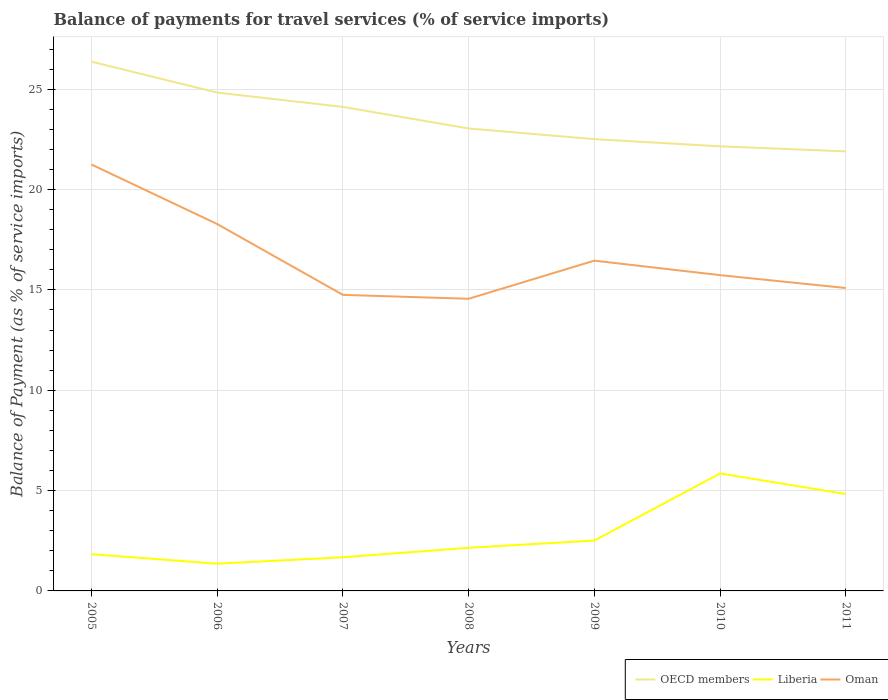Does the line corresponding to OECD members intersect with the line corresponding to Oman?
Your response must be concise. No. Is the number of lines equal to the number of legend labels?
Your answer should be very brief. Yes. Across all years, what is the maximum balance of payments for travel services in Oman?
Your answer should be very brief. 14.56. In which year was the balance of payments for travel services in OECD members maximum?
Ensure brevity in your answer.  2011. What is the total balance of payments for travel services in Oman in the graph?
Ensure brevity in your answer.  0.72. What is the difference between the highest and the second highest balance of payments for travel services in Oman?
Your answer should be compact. 6.69. What is the difference between the highest and the lowest balance of payments for travel services in Oman?
Your answer should be very brief. 2. Is the balance of payments for travel services in Oman strictly greater than the balance of payments for travel services in Liberia over the years?
Your answer should be compact. No. How many years are there in the graph?
Make the answer very short. 7. What is the difference between two consecutive major ticks on the Y-axis?
Give a very brief answer. 5. Are the values on the major ticks of Y-axis written in scientific E-notation?
Offer a terse response. No. Does the graph contain any zero values?
Your response must be concise. No. How many legend labels are there?
Your response must be concise. 3. What is the title of the graph?
Offer a terse response. Balance of payments for travel services (% of service imports). Does "Czech Republic" appear as one of the legend labels in the graph?
Give a very brief answer. No. What is the label or title of the Y-axis?
Keep it short and to the point. Balance of Payment (as % of service imports). What is the Balance of Payment (as % of service imports) in OECD members in 2005?
Keep it short and to the point. 26.37. What is the Balance of Payment (as % of service imports) of Liberia in 2005?
Give a very brief answer. 1.83. What is the Balance of Payment (as % of service imports) of Oman in 2005?
Give a very brief answer. 21.25. What is the Balance of Payment (as % of service imports) in OECD members in 2006?
Your answer should be compact. 24.83. What is the Balance of Payment (as % of service imports) of Liberia in 2006?
Provide a succinct answer. 1.36. What is the Balance of Payment (as % of service imports) in Oman in 2006?
Your response must be concise. 18.28. What is the Balance of Payment (as % of service imports) in OECD members in 2007?
Ensure brevity in your answer.  24.12. What is the Balance of Payment (as % of service imports) of Liberia in 2007?
Provide a succinct answer. 1.68. What is the Balance of Payment (as % of service imports) in Oman in 2007?
Give a very brief answer. 14.75. What is the Balance of Payment (as % of service imports) of OECD members in 2008?
Provide a succinct answer. 23.04. What is the Balance of Payment (as % of service imports) in Liberia in 2008?
Give a very brief answer. 2.15. What is the Balance of Payment (as % of service imports) of Oman in 2008?
Provide a succinct answer. 14.56. What is the Balance of Payment (as % of service imports) in OECD members in 2009?
Your answer should be compact. 22.51. What is the Balance of Payment (as % of service imports) of Liberia in 2009?
Give a very brief answer. 2.51. What is the Balance of Payment (as % of service imports) in Oman in 2009?
Your answer should be very brief. 16.46. What is the Balance of Payment (as % of service imports) in OECD members in 2010?
Provide a short and direct response. 22.15. What is the Balance of Payment (as % of service imports) of Liberia in 2010?
Offer a terse response. 5.85. What is the Balance of Payment (as % of service imports) of Oman in 2010?
Provide a short and direct response. 15.74. What is the Balance of Payment (as % of service imports) of OECD members in 2011?
Offer a terse response. 21.9. What is the Balance of Payment (as % of service imports) in Liberia in 2011?
Your answer should be compact. 4.83. What is the Balance of Payment (as % of service imports) of Oman in 2011?
Provide a short and direct response. 15.09. Across all years, what is the maximum Balance of Payment (as % of service imports) of OECD members?
Offer a very short reply. 26.37. Across all years, what is the maximum Balance of Payment (as % of service imports) of Liberia?
Provide a succinct answer. 5.85. Across all years, what is the maximum Balance of Payment (as % of service imports) in Oman?
Keep it short and to the point. 21.25. Across all years, what is the minimum Balance of Payment (as % of service imports) of OECD members?
Offer a very short reply. 21.9. Across all years, what is the minimum Balance of Payment (as % of service imports) of Liberia?
Make the answer very short. 1.36. Across all years, what is the minimum Balance of Payment (as % of service imports) of Oman?
Ensure brevity in your answer.  14.56. What is the total Balance of Payment (as % of service imports) in OECD members in the graph?
Provide a short and direct response. 164.94. What is the total Balance of Payment (as % of service imports) of Liberia in the graph?
Give a very brief answer. 20.21. What is the total Balance of Payment (as % of service imports) of Oman in the graph?
Provide a short and direct response. 116.13. What is the difference between the Balance of Payment (as % of service imports) in OECD members in 2005 and that in 2006?
Your answer should be compact. 1.54. What is the difference between the Balance of Payment (as % of service imports) in Liberia in 2005 and that in 2006?
Ensure brevity in your answer.  0.47. What is the difference between the Balance of Payment (as % of service imports) of Oman in 2005 and that in 2006?
Your answer should be very brief. 2.97. What is the difference between the Balance of Payment (as % of service imports) of OECD members in 2005 and that in 2007?
Keep it short and to the point. 2.25. What is the difference between the Balance of Payment (as % of service imports) in Liberia in 2005 and that in 2007?
Provide a short and direct response. 0.15. What is the difference between the Balance of Payment (as % of service imports) in Oman in 2005 and that in 2007?
Offer a very short reply. 6.5. What is the difference between the Balance of Payment (as % of service imports) of OECD members in 2005 and that in 2008?
Your answer should be very brief. 3.33. What is the difference between the Balance of Payment (as % of service imports) in Liberia in 2005 and that in 2008?
Keep it short and to the point. -0.32. What is the difference between the Balance of Payment (as % of service imports) of Oman in 2005 and that in 2008?
Give a very brief answer. 6.69. What is the difference between the Balance of Payment (as % of service imports) of OECD members in 2005 and that in 2009?
Offer a terse response. 3.86. What is the difference between the Balance of Payment (as % of service imports) of Liberia in 2005 and that in 2009?
Your answer should be compact. -0.68. What is the difference between the Balance of Payment (as % of service imports) of Oman in 2005 and that in 2009?
Make the answer very short. 4.79. What is the difference between the Balance of Payment (as % of service imports) of OECD members in 2005 and that in 2010?
Offer a terse response. 4.22. What is the difference between the Balance of Payment (as % of service imports) in Liberia in 2005 and that in 2010?
Offer a terse response. -4.02. What is the difference between the Balance of Payment (as % of service imports) in Oman in 2005 and that in 2010?
Your response must be concise. 5.51. What is the difference between the Balance of Payment (as % of service imports) in OECD members in 2005 and that in 2011?
Provide a succinct answer. 4.47. What is the difference between the Balance of Payment (as % of service imports) in Liberia in 2005 and that in 2011?
Offer a very short reply. -3. What is the difference between the Balance of Payment (as % of service imports) of Oman in 2005 and that in 2011?
Give a very brief answer. 6.16. What is the difference between the Balance of Payment (as % of service imports) in OECD members in 2006 and that in 2007?
Ensure brevity in your answer.  0.71. What is the difference between the Balance of Payment (as % of service imports) in Liberia in 2006 and that in 2007?
Give a very brief answer. -0.32. What is the difference between the Balance of Payment (as % of service imports) of Oman in 2006 and that in 2007?
Offer a terse response. 3.53. What is the difference between the Balance of Payment (as % of service imports) in OECD members in 2006 and that in 2008?
Your answer should be very brief. 1.79. What is the difference between the Balance of Payment (as % of service imports) of Liberia in 2006 and that in 2008?
Your response must be concise. -0.79. What is the difference between the Balance of Payment (as % of service imports) in Oman in 2006 and that in 2008?
Make the answer very short. 3.73. What is the difference between the Balance of Payment (as % of service imports) in OECD members in 2006 and that in 2009?
Give a very brief answer. 2.32. What is the difference between the Balance of Payment (as % of service imports) of Liberia in 2006 and that in 2009?
Your response must be concise. -1.15. What is the difference between the Balance of Payment (as % of service imports) in Oman in 2006 and that in 2009?
Your answer should be compact. 1.82. What is the difference between the Balance of Payment (as % of service imports) in OECD members in 2006 and that in 2010?
Keep it short and to the point. 2.68. What is the difference between the Balance of Payment (as % of service imports) of Liberia in 2006 and that in 2010?
Offer a terse response. -4.5. What is the difference between the Balance of Payment (as % of service imports) in Oman in 2006 and that in 2010?
Your response must be concise. 2.55. What is the difference between the Balance of Payment (as % of service imports) of OECD members in 2006 and that in 2011?
Give a very brief answer. 2.93. What is the difference between the Balance of Payment (as % of service imports) in Liberia in 2006 and that in 2011?
Make the answer very short. -3.47. What is the difference between the Balance of Payment (as % of service imports) of Oman in 2006 and that in 2011?
Your answer should be compact. 3.19. What is the difference between the Balance of Payment (as % of service imports) in OECD members in 2007 and that in 2008?
Ensure brevity in your answer.  1.08. What is the difference between the Balance of Payment (as % of service imports) of Liberia in 2007 and that in 2008?
Provide a succinct answer. -0.47. What is the difference between the Balance of Payment (as % of service imports) of Oman in 2007 and that in 2008?
Make the answer very short. 0.19. What is the difference between the Balance of Payment (as % of service imports) of OECD members in 2007 and that in 2009?
Provide a short and direct response. 1.61. What is the difference between the Balance of Payment (as % of service imports) in Liberia in 2007 and that in 2009?
Offer a very short reply. -0.83. What is the difference between the Balance of Payment (as % of service imports) in Oman in 2007 and that in 2009?
Make the answer very short. -1.71. What is the difference between the Balance of Payment (as % of service imports) of OECD members in 2007 and that in 2010?
Your answer should be compact. 1.97. What is the difference between the Balance of Payment (as % of service imports) of Liberia in 2007 and that in 2010?
Give a very brief answer. -4.18. What is the difference between the Balance of Payment (as % of service imports) in Oman in 2007 and that in 2010?
Offer a very short reply. -0.98. What is the difference between the Balance of Payment (as % of service imports) in OECD members in 2007 and that in 2011?
Your answer should be very brief. 2.22. What is the difference between the Balance of Payment (as % of service imports) in Liberia in 2007 and that in 2011?
Ensure brevity in your answer.  -3.15. What is the difference between the Balance of Payment (as % of service imports) in Oman in 2007 and that in 2011?
Ensure brevity in your answer.  -0.34. What is the difference between the Balance of Payment (as % of service imports) of OECD members in 2008 and that in 2009?
Your answer should be very brief. 0.53. What is the difference between the Balance of Payment (as % of service imports) in Liberia in 2008 and that in 2009?
Your answer should be compact. -0.36. What is the difference between the Balance of Payment (as % of service imports) in Oman in 2008 and that in 2009?
Your answer should be very brief. -1.9. What is the difference between the Balance of Payment (as % of service imports) of OECD members in 2008 and that in 2010?
Your answer should be very brief. 0.89. What is the difference between the Balance of Payment (as % of service imports) in Liberia in 2008 and that in 2010?
Ensure brevity in your answer.  -3.7. What is the difference between the Balance of Payment (as % of service imports) of Oman in 2008 and that in 2010?
Give a very brief answer. -1.18. What is the difference between the Balance of Payment (as % of service imports) of OECD members in 2008 and that in 2011?
Make the answer very short. 1.14. What is the difference between the Balance of Payment (as % of service imports) in Liberia in 2008 and that in 2011?
Offer a terse response. -2.68. What is the difference between the Balance of Payment (as % of service imports) in Oman in 2008 and that in 2011?
Your answer should be very brief. -0.54. What is the difference between the Balance of Payment (as % of service imports) in OECD members in 2009 and that in 2010?
Provide a short and direct response. 0.36. What is the difference between the Balance of Payment (as % of service imports) of Liberia in 2009 and that in 2010?
Offer a very short reply. -3.35. What is the difference between the Balance of Payment (as % of service imports) of Oman in 2009 and that in 2010?
Keep it short and to the point. 0.72. What is the difference between the Balance of Payment (as % of service imports) in OECD members in 2009 and that in 2011?
Offer a very short reply. 0.61. What is the difference between the Balance of Payment (as % of service imports) of Liberia in 2009 and that in 2011?
Offer a very short reply. -2.32. What is the difference between the Balance of Payment (as % of service imports) in Oman in 2009 and that in 2011?
Make the answer very short. 1.36. What is the difference between the Balance of Payment (as % of service imports) of OECD members in 2010 and that in 2011?
Make the answer very short. 0.25. What is the difference between the Balance of Payment (as % of service imports) of Oman in 2010 and that in 2011?
Give a very brief answer. 0.64. What is the difference between the Balance of Payment (as % of service imports) of OECD members in 2005 and the Balance of Payment (as % of service imports) of Liberia in 2006?
Offer a terse response. 25.02. What is the difference between the Balance of Payment (as % of service imports) of OECD members in 2005 and the Balance of Payment (as % of service imports) of Oman in 2006?
Your answer should be compact. 8.09. What is the difference between the Balance of Payment (as % of service imports) in Liberia in 2005 and the Balance of Payment (as % of service imports) in Oman in 2006?
Provide a short and direct response. -16.45. What is the difference between the Balance of Payment (as % of service imports) of OECD members in 2005 and the Balance of Payment (as % of service imports) of Liberia in 2007?
Give a very brief answer. 24.7. What is the difference between the Balance of Payment (as % of service imports) in OECD members in 2005 and the Balance of Payment (as % of service imports) in Oman in 2007?
Your answer should be very brief. 11.62. What is the difference between the Balance of Payment (as % of service imports) of Liberia in 2005 and the Balance of Payment (as % of service imports) of Oman in 2007?
Offer a very short reply. -12.92. What is the difference between the Balance of Payment (as % of service imports) in OECD members in 2005 and the Balance of Payment (as % of service imports) in Liberia in 2008?
Give a very brief answer. 24.22. What is the difference between the Balance of Payment (as % of service imports) in OECD members in 2005 and the Balance of Payment (as % of service imports) in Oman in 2008?
Ensure brevity in your answer.  11.82. What is the difference between the Balance of Payment (as % of service imports) in Liberia in 2005 and the Balance of Payment (as % of service imports) in Oman in 2008?
Your answer should be compact. -12.73. What is the difference between the Balance of Payment (as % of service imports) in OECD members in 2005 and the Balance of Payment (as % of service imports) in Liberia in 2009?
Keep it short and to the point. 23.86. What is the difference between the Balance of Payment (as % of service imports) in OECD members in 2005 and the Balance of Payment (as % of service imports) in Oman in 2009?
Give a very brief answer. 9.91. What is the difference between the Balance of Payment (as % of service imports) in Liberia in 2005 and the Balance of Payment (as % of service imports) in Oman in 2009?
Ensure brevity in your answer.  -14.63. What is the difference between the Balance of Payment (as % of service imports) in OECD members in 2005 and the Balance of Payment (as % of service imports) in Liberia in 2010?
Your answer should be very brief. 20.52. What is the difference between the Balance of Payment (as % of service imports) of OECD members in 2005 and the Balance of Payment (as % of service imports) of Oman in 2010?
Offer a very short reply. 10.64. What is the difference between the Balance of Payment (as % of service imports) of Liberia in 2005 and the Balance of Payment (as % of service imports) of Oman in 2010?
Offer a terse response. -13.91. What is the difference between the Balance of Payment (as % of service imports) in OECD members in 2005 and the Balance of Payment (as % of service imports) in Liberia in 2011?
Your response must be concise. 21.54. What is the difference between the Balance of Payment (as % of service imports) in OECD members in 2005 and the Balance of Payment (as % of service imports) in Oman in 2011?
Your response must be concise. 11.28. What is the difference between the Balance of Payment (as % of service imports) in Liberia in 2005 and the Balance of Payment (as % of service imports) in Oman in 2011?
Offer a terse response. -13.26. What is the difference between the Balance of Payment (as % of service imports) in OECD members in 2006 and the Balance of Payment (as % of service imports) in Liberia in 2007?
Your answer should be compact. 23.16. What is the difference between the Balance of Payment (as % of service imports) in OECD members in 2006 and the Balance of Payment (as % of service imports) in Oman in 2007?
Your response must be concise. 10.08. What is the difference between the Balance of Payment (as % of service imports) of Liberia in 2006 and the Balance of Payment (as % of service imports) of Oman in 2007?
Your answer should be compact. -13.4. What is the difference between the Balance of Payment (as % of service imports) in OECD members in 2006 and the Balance of Payment (as % of service imports) in Liberia in 2008?
Make the answer very short. 22.68. What is the difference between the Balance of Payment (as % of service imports) of OECD members in 2006 and the Balance of Payment (as % of service imports) of Oman in 2008?
Give a very brief answer. 10.27. What is the difference between the Balance of Payment (as % of service imports) in Liberia in 2006 and the Balance of Payment (as % of service imports) in Oman in 2008?
Provide a short and direct response. -13.2. What is the difference between the Balance of Payment (as % of service imports) of OECD members in 2006 and the Balance of Payment (as % of service imports) of Liberia in 2009?
Your answer should be very brief. 22.32. What is the difference between the Balance of Payment (as % of service imports) of OECD members in 2006 and the Balance of Payment (as % of service imports) of Oman in 2009?
Your answer should be compact. 8.37. What is the difference between the Balance of Payment (as % of service imports) of Liberia in 2006 and the Balance of Payment (as % of service imports) of Oman in 2009?
Your answer should be compact. -15.1. What is the difference between the Balance of Payment (as % of service imports) of OECD members in 2006 and the Balance of Payment (as % of service imports) of Liberia in 2010?
Offer a very short reply. 18.98. What is the difference between the Balance of Payment (as % of service imports) of OECD members in 2006 and the Balance of Payment (as % of service imports) of Oman in 2010?
Your answer should be compact. 9.1. What is the difference between the Balance of Payment (as % of service imports) of Liberia in 2006 and the Balance of Payment (as % of service imports) of Oman in 2010?
Make the answer very short. -14.38. What is the difference between the Balance of Payment (as % of service imports) in OECD members in 2006 and the Balance of Payment (as % of service imports) in Liberia in 2011?
Offer a very short reply. 20. What is the difference between the Balance of Payment (as % of service imports) of OECD members in 2006 and the Balance of Payment (as % of service imports) of Oman in 2011?
Ensure brevity in your answer.  9.74. What is the difference between the Balance of Payment (as % of service imports) in Liberia in 2006 and the Balance of Payment (as % of service imports) in Oman in 2011?
Offer a terse response. -13.74. What is the difference between the Balance of Payment (as % of service imports) in OECD members in 2007 and the Balance of Payment (as % of service imports) in Liberia in 2008?
Your answer should be compact. 21.97. What is the difference between the Balance of Payment (as % of service imports) of OECD members in 2007 and the Balance of Payment (as % of service imports) of Oman in 2008?
Give a very brief answer. 9.56. What is the difference between the Balance of Payment (as % of service imports) in Liberia in 2007 and the Balance of Payment (as % of service imports) in Oman in 2008?
Ensure brevity in your answer.  -12.88. What is the difference between the Balance of Payment (as % of service imports) in OECD members in 2007 and the Balance of Payment (as % of service imports) in Liberia in 2009?
Your response must be concise. 21.61. What is the difference between the Balance of Payment (as % of service imports) in OECD members in 2007 and the Balance of Payment (as % of service imports) in Oman in 2009?
Offer a very short reply. 7.66. What is the difference between the Balance of Payment (as % of service imports) of Liberia in 2007 and the Balance of Payment (as % of service imports) of Oman in 2009?
Your answer should be compact. -14.78. What is the difference between the Balance of Payment (as % of service imports) in OECD members in 2007 and the Balance of Payment (as % of service imports) in Liberia in 2010?
Keep it short and to the point. 18.27. What is the difference between the Balance of Payment (as % of service imports) of OECD members in 2007 and the Balance of Payment (as % of service imports) of Oman in 2010?
Ensure brevity in your answer.  8.38. What is the difference between the Balance of Payment (as % of service imports) of Liberia in 2007 and the Balance of Payment (as % of service imports) of Oman in 2010?
Offer a very short reply. -14.06. What is the difference between the Balance of Payment (as % of service imports) of OECD members in 2007 and the Balance of Payment (as % of service imports) of Liberia in 2011?
Provide a succinct answer. 19.29. What is the difference between the Balance of Payment (as % of service imports) in OECD members in 2007 and the Balance of Payment (as % of service imports) in Oman in 2011?
Provide a short and direct response. 9.03. What is the difference between the Balance of Payment (as % of service imports) in Liberia in 2007 and the Balance of Payment (as % of service imports) in Oman in 2011?
Give a very brief answer. -13.42. What is the difference between the Balance of Payment (as % of service imports) in OECD members in 2008 and the Balance of Payment (as % of service imports) in Liberia in 2009?
Offer a very short reply. 20.53. What is the difference between the Balance of Payment (as % of service imports) in OECD members in 2008 and the Balance of Payment (as % of service imports) in Oman in 2009?
Ensure brevity in your answer.  6.59. What is the difference between the Balance of Payment (as % of service imports) of Liberia in 2008 and the Balance of Payment (as % of service imports) of Oman in 2009?
Make the answer very short. -14.31. What is the difference between the Balance of Payment (as % of service imports) in OECD members in 2008 and the Balance of Payment (as % of service imports) in Liberia in 2010?
Provide a short and direct response. 17.19. What is the difference between the Balance of Payment (as % of service imports) in OECD members in 2008 and the Balance of Payment (as % of service imports) in Oman in 2010?
Your answer should be compact. 7.31. What is the difference between the Balance of Payment (as % of service imports) in Liberia in 2008 and the Balance of Payment (as % of service imports) in Oman in 2010?
Your answer should be very brief. -13.59. What is the difference between the Balance of Payment (as % of service imports) of OECD members in 2008 and the Balance of Payment (as % of service imports) of Liberia in 2011?
Make the answer very short. 18.22. What is the difference between the Balance of Payment (as % of service imports) of OECD members in 2008 and the Balance of Payment (as % of service imports) of Oman in 2011?
Keep it short and to the point. 7.95. What is the difference between the Balance of Payment (as % of service imports) of Liberia in 2008 and the Balance of Payment (as % of service imports) of Oman in 2011?
Offer a terse response. -12.95. What is the difference between the Balance of Payment (as % of service imports) of OECD members in 2009 and the Balance of Payment (as % of service imports) of Liberia in 2010?
Your answer should be compact. 16.66. What is the difference between the Balance of Payment (as % of service imports) in OECD members in 2009 and the Balance of Payment (as % of service imports) in Oman in 2010?
Keep it short and to the point. 6.78. What is the difference between the Balance of Payment (as % of service imports) of Liberia in 2009 and the Balance of Payment (as % of service imports) of Oman in 2010?
Your answer should be very brief. -13.23. What is the difference between the Balance of Payment (as % of service imports) of OECD members in 2009 and the Balance of Payment (as % of service imports) of Liberia in 2011?
Offer a very short reply. 17.68. What is the difference between the Balance of Payment (as % of service imports) in OECD members in 2009 and the Balance of Payment (as % of service imports) in Oman in 2011?
Provide a short and direct response. 7.42. What is the difference between the Balance of Payment (as % of service imports) of Liberia in 2009 and the Balance of Payment (as % of service imports) of Oman in 2011?
Your response must be concise. -12.59. What is the difference between the Balance of Payment (as % of service imports) of OECD members in 2010 and the Balance of Payment (as % of service imports) of Liberia in 2011?
Keep it short and to the point. 17.33. What is the difference between the Balance of Payment (as % of service imports) in OECD members in 2010 and the Balance of Payment (as % of service imports) in Oman in 2011?
Give a very brief answer. 7.06. What is the difference between the Balance of Payment (as % of service imports) of Liberia in 2010 and the Balance of Payment (as % of service imports) of Oman in 2011?
Provide a succinct answer. -9.24. What is the average Balance of Payment (as % of service imports) in OECD members per year?
Your answer should be very brief. 23.56. What is the average Balance of Payment (as % of service imports) of Liberia per year?
Your answer should be very brief. 2.89. What is the average Balance of Payment (as % of service imports) in Oman per year?
Keep it short and to the point. 16.59. In the year 2005, what is the difference between the Balance of Payment (as % of service imports) of OECD members and Balance of Payment (as % of service imports) of Liberia?
Offer a terse response. 24.54. In the year 2005, what is the difference between the Balance of Payment (as % of service imports) in OECD members and Balance of Payment (as % of service imports) in Oman?
Keep it short and to the point. 5.12. In the year 2005, what is the difference between the Balance of Payment (as % of service imports) of Liberia and Balance of Payment (as % of service imports) of Oman?
Provide a succinct answer. -19.42. In the year 2006, what is the difference between the Balance of Payment (as % of service imports) in OECD members and Balance of Payment (as % of service imports) in Liberia?
Ensure brevity in your answer.  23.47. In the year 2006, what is the difference between the Balance of Payment (as % of service imports) in OECD members and Balance of Payment (as % of service imports) in Oman?
Keep it short and to the point. 6.55. In the year 2006, what is the difference between the Balance of Payment (as % of service imports) of Liberia and Balance of Payment (as % of service imports) of Oman?
Ensure brevity in your answer.  -16.93. In the year 2007, what is the difference between the Balance of Payment (as % of service imports) in OECD members and Balance of Payment (as % of service imports) in Liberia?
Your answer should be very brief. 22.44. In the year 2007, what is the difference between the Balance of Payment (as % of service imports) in OECD members and Balance of Payment (as % of service imports) in Oman?
Provide a succinct answer. 9.37. In the year 2007, what is the difference between the Balance of Payment (as % of service imports) in Liberia and Balance of Payment (as % of service imports) in Oman?
Your answer should be very brief. -13.08. In the year 2008, what is the difference between the Balance of Payment (as % of service imports) in OECD members and Balance of Payment (as % of service imports) in Liberia?
Provide a short and direct response. 20.89. In the year 2008, what is the difference between the Balance of Payment (as % of service imports) of OECD members and Balance of Payment (as % of service imports) of Oman?
Make the answer very short. 8.49. In the year 2008, what is the difference between the Balance of Payment (as % of service imports) of Liberia and Balance of Payment (as % of service imports) of Oman?
Offer a very short reply. -12.41. In the year 2009, what is the difference between the Balance of Payment (as % of service imports) in OECD members and Balance of Payment (as % of service imports) in Liberia?
Provide a short and direct response. 20. In the year 2009, what is the difference between the Balance of Payment (as % of service imports) in OECD members and Balance of Payment (as % of service imports) in Oman?
Your answer should be compact. 6.05. In the year 2009, what is the difference between the Balance of Payment (as % of service imports) of Liberia and Balance of Payment (as % of service imports) of Oman?
Make the answer very short. -13.95. In the year 2010, what is the difference between the Balance of Payment (as % of service imports) of OECD members and Balance of Payment (as % of service imports) of Liberia?
Offer a very short reply. 16.3. In the year 2010, what is the difference between the Balance of Payment (as % of service imports) of OECD members and Balance of Payment (as % of service imports) of Oman?
Your answer should be compact. 6.42. In the year 2010, what is the difference between the Balance of Payment (as % of service imports) of Liberia and Balance of Payment (as % of service imports) of Oman?
Ensure brevity in your answer.  -9.88. In the year 2011, what is the difference between the Balance of Payment (as % of service imports) of OECD members and Balance of Payment (as % of service imports) of Liberia?
Your answer should be compact. 17.08. In the year 2011, what is the difference between the Balance of Payment (as % of service imports) in OECD members and Balance of Payment (as % of service imports) in Oman?
Your response must be concise. 6.81. In the year 2011, what is the difference between the Balance of Payment (as % of service imports) in Liberia and Balance of Payment (as % of service imports) in Oman?
Offer a terse response. -10.27. What is the ratio of the Balance of Payment (as % of service imports) of OECD members in 2005 to that in 2006?
Give a very brief answer. 1.06. What is the ratio of the Balance of Payment (as % of service imports) of Liberia in 2005 to that in 2006?
Your response must be concise. 1.35. What is the ratio of the Balance of Payment (as % of service imports) of Oman in 2005 to that in 2006?
Make the answer very short. 1.16. What is the ratio of the Balance of Payment (as % of service imports) in OECD members in 2005 to that in 2007?
Your response must be concise. 1.09. What is the ratio of the Balance of Payment (as % of service imports) of Liberia in 2005 to that in 2007?
Give a very brief answer. 1.09. What is the ratio of the Balance of Payment (as % of service imports) in Oman in 2005 to that in 2007?
Provide a succinct answer. 1.44. What is the ratio of the Balance of Payment (as % of service imports) in OECD members in 2005 to that in 2008?
Give a very brief answer. 1.14. What is the ratio of the Balance of Payment (as % of service imports) in Liberia in 2005 to that in 2008?
Offer a terse response. 0.85. What is the ratio of the Balance of Payment (as % of service imports) in Oman in 2005 to that in 2008?
Your answer should be very brief. 1.46. What is the ratio of the Balance of Payment (as % of service imports) of OECD members in 2005 to that in 2009?
Your answer should be compact. 1.17. What is the ratio of the Balance of Payment (as % of service imports) in Liberia in 2005 to that in 2009?
Provide a short and direct response. 0.73. What is the ratio of the Balance of Payment (as % of service imports) in Oman in 2005 to that in 2009?
Give a very brief answer. 1.29. What is the ratio of the Balance of Payment (as % of service imports) of OECD members in 2005 to that in 2010?
Keep it short and to the point. 1.19. What is the ratio of the Balance of Payment (as % of service imports) in Liberia in 2005 to that in 2010?
Your response must be concise. 0.31. What is the ratio of the Balance of Payment (as % of service imports) in Oman in 2005 to that in 2010?
Your response must be concise. 1.35. What is the ratio of the Balance of Payment (as % of service imports) of OECD members in 2005 to that in 2011?
Your answer should be very brief. 1.2. What is the ratio of the Balance of Payment (as % of service imports) of Liberia in 2005 to that in 2011?
Your answer should be compact. 0.38. What is the ratio of the Balance of Payment (as % of service imports) in Oman in 2005 to that in 2011?
Provide a succinct answer. 1.41. What is the ratio of the Balance of Payment (as % of service imports) in OECD members in 2006 to that in 2007?
Keep it short and to the point. 1.03. What is the ratio of the Balance of Payment (as % of service imports) of Liberia in 2006 to that in 2007?
Keep it short and to the point. 0.81. What is the ratio of the Balance of Payment (as % of service imports) of Oman in 2006 to that in 2007?
Your answer should be very brief. 1.24. What is the ratio of the Balance of Payment (as % of service imports) of OECD members in 2006 to that in 2008?
Your response must be concise. 1.08. What is the ratio of the Balance of Payment (as % of service imports) of Liberia in 2006 to that in 2008?
Keep it short and to the point. 0.63. What is the ratio of the Balance of Payment (as % of service imports) in Oman in 2006 to that in 2008?
Offer a terse response. 1.26. What is the ratio of the Balance of Payment (as % of service imports) of OECD members in 2006 to that in 2009?
Make the answer very short. 1.1. What is the ratio of the Balance of Payment (as % of service imports) in Liberia in 2006 to that in 2009?
Make the answer very short. 0.54. What is the ratio of the Balance of Payment (as % of service imports) of Oman in 2006 to that in 2009?
Keep it short and to the point. 1.11. What is the ratio of the Balance of Payment (as % of service imports) in OECD members in 2006 to that in 2010?
Offer a terse response. 1.12. What is the ratio of the Balance of Payment (as % of service imports) of Liberia in 2006 to that in 2010?
Ensure brevity in your answer.  0.23. What is the ratio of the Balance of Payment (as % of service imports) in Oman in 2006 to that in 2010?
Provide a short and direct response. 1.16. What is the ratio of the Balance of Payment (as % of service imports) in OECD members in 2006 to that in 2011?
Offer a very short reply. 1.13. What is the ratio of the Balance of Payment (as % of service imports) in Liberia in 2006 to that in 2011?
Make the answer very short. 0.28. What is the ratio of the Balance of Payment (as % of service imports) of Oman in 2006 to that in 2011?
Offer a very short reply. 1.21. What is the ratio of the Balance of Payment (as % of service imports) in OECD members in 2007 to that in 2008?
Your answer should be very brief. 1.05. What is the ratio of the Balance of Payment (as % of service imports) of Liberia in 2007 to that in 2008?
Offer a very short reply. 0.78. What is the ratio of the Balance of Payment (as % of service imports) in Oman in 2007 to that in 2008?
Keep it short and to the point. 1.01. What is the ratio of the Balance of Payment (as % of service imports) of OECD members in 2007 to that in 2009?
Your answer should be very brief. 1.07. What is the ratio of the Balance of Payment (as % of service imports) of Liberia in 2007 to that in 2009?
Provide a succinct answer. 0.67. What is the ratio of the Balance of Payment (as % of service imports) of Oman in 2007 to that in 2009?
Offer a terse response. 0.9. What is the ratio of the Balance of Payment (as % of service imports) in OECD members in 2007 to that in 2010?
Ensure brevity in your answer.  1.09. What is the ratio of the Balance of Payment (as % of service imports) in Liberia in 2007 to that in 2010?
Keep it short and to the point. 0.29. What is the ratio of the Balance of Payment (as % of service imports) in Oman in 2007 to that in 2010?
Provide a succinct answer. 0.94. What is the ratio of the Balance of Payment (as % of service imports) of OECD members in 2007 to that in 2011?
Provide a short and direct response. 1.1. What is the ratio of the Balance of Payment (as % of service imports) of Liberia in 2007 to that in 2011?
Offer a very short reply. 0.35. What is the ratio of the Balance of Payment (as % of service imports) in Oman in 2007 to that in 2011?
Keep it short and to the point. 0.98. What is the ratio of the Balance of Payment (as % of service imports) of OECD members in 2008 to that in 2009?
Ensure brevity in your answer.  1.02. What is the ratio of the Balance of Payment (as % of service imports) in Liberia in 2008 to that in 2009?
Provide a succinct answer. 0.86. What is the ratio of the Balance of Payment (as % of service imports) of Oman in 2008 to that in 2009?
Ensure brevity in your answer.  0.88. What is the ratio of the Balance of Payment (as % of service imports) in OECD members in 2008 to that in 2010?
Provide a succinct answer. 1.04. What is the ratio of the Balance of Payment (as % of service imports) of Liberia in 2008 to that in 2010?
Offer a very short reply. 0.37. What is the ratio of the Balance of Payment (as % of service imports) of Oman in 2008 to that in 2010?
Offer a terse response. 0.93. What is the ratio of the Balance of Payment (as % of service imports) of OECD members in 2008 to that in 2011?
Provide a short and direct response. 1.05. What is the ratio of the Balance of Payment (as % of service imports) in Liberia in 2008 to that in 2011?
Your answer should be compact. 0.45. What is the ratio of the Balance of Payment (as % of service imports) of Oman in 2008 to that in 2011?
Provide a succinct answer. 0.96. What is the ratio of the Balance of Payment (as % of service imports) in OECD members in 2009 to that in 2010?
Your answer should be very brief. 1.02. What is the ratio of the Balance of Payment (as % of service imports) of Liberia in 2009 to that in 2010?
Offer a very short reply. 0.43. What is the ratio of the Balance of Payment (as % of service imports) in Oman in 2009 to that in 2010?
Your answer should be compact. 1.05. What is the ratio of the Balance of Payment (as % of service imports) in OECD members in 2009 to that in 2011?
Your answer should be very brief. 1.03. What is the ratio of the Balance of Payment (as % of service imports) in Liberia in 2009 to that in 2011?
Provide a succinct answer. 0.52. What is the ratio of the Balance of Payment (as % of service imports) in Oman in 2009 to that in 2011?
Provide a succinct answer. 1.09. What is the ratio of the Balance of Payment (as % of service imports) of OECD members in 2010 to that in 2011?
Your response must be concise. 1.01. What is the ratio of the Balance of Payment (as % of service imports) in Liberia in 2010 to that in 2011?
Ensure brevity in your answer.  1.21. What is the ratio of the Balance of Payment (as % of service imports) in Oman in 2010 to that in 2011?
Offer a terse response. 1.04. What is the difference between the highest and the second highest Balance of Payment (as % of service imports) of OECD members?
Keep it short and to the point. 1.54. What is the difference between the highest and the second highest Balance of Payment (as % of service imports) of Oman?
Your answer should be very brief. 2.97. What is the difference between the highest and the lowest Balance of Payment (as % of service imports) in OECD members?
Provide a succinct answer. 4.47. What is the difference between the highest and the lowest Balance of Payment (as % of service imports) in Liberia?
Your answer should be very brief. 4.5. What is the difference between the highest and the lowest Balance of Payment (as % of service imports) of Oman?
Make the answer very short. 6.69. 